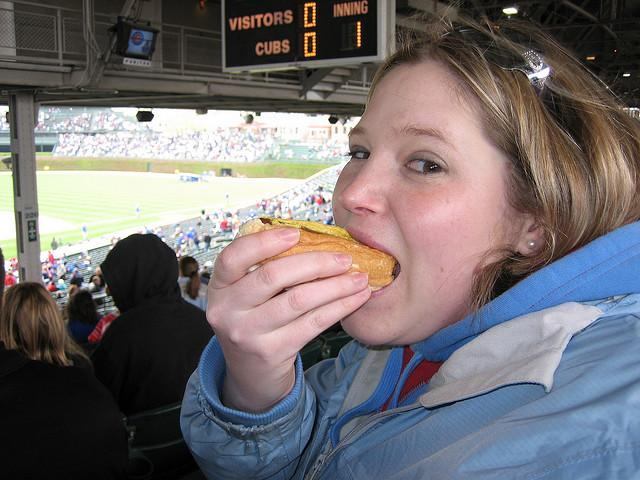The condiment on this food comes from where?

Choices:
A) mustard seed
B) echinacea plant
C) tomato plant
D) wasabi leaf mustard seed 